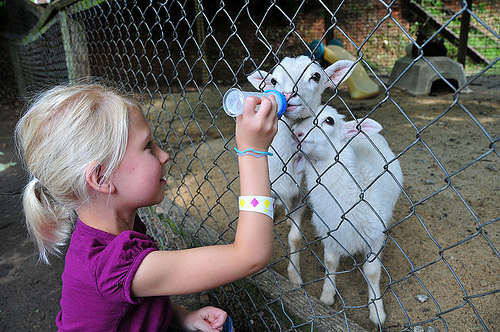<image>
Is there a bottle in the fence? Yes. The bottle is contained within or inside the fence, showing a containment relationship. 